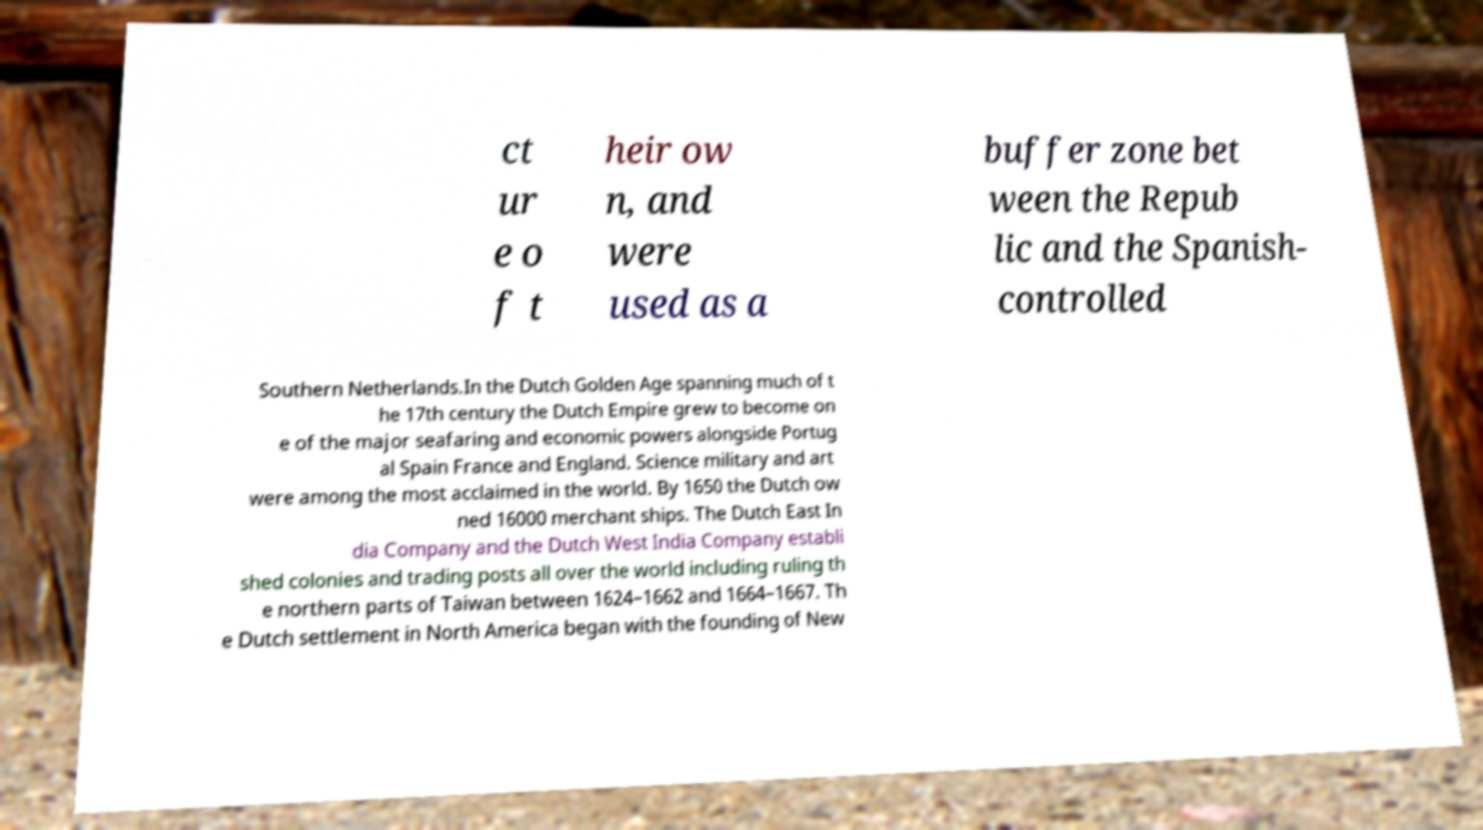Can you read and provide the text displayed in the image?This photo seems to have some interesting text. Can you extract and type it out for me? ct ur e o f t heir ow n, and were used as a buffer zone bet ween the Repub lic and the Spanish- controlled Southern Netherlands.In the Dutch Golden Age spanning much of t he 17th century the Dutch Empire grew to become on e of the major seafaring and economic powers alongside Portug al Spain France and England. Science military and art were among the most acclaimed in the world. By 1650 the Dutch ow ned 16000 merchant ships. The Dutch East In dia Company and the Dutch West India Company establi shed colonies and trading posts all over the world including ruling th e northern parts of Taiwan between 1624–1662 and 1664–1667. Th e Dutch settlement in North America began with the founding of New 